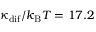<formula> <loc_0><loc_0><loc_500><loc_500>\kappa _ { d i f } / k _ { B } T = 1 7 . 2</formula> 